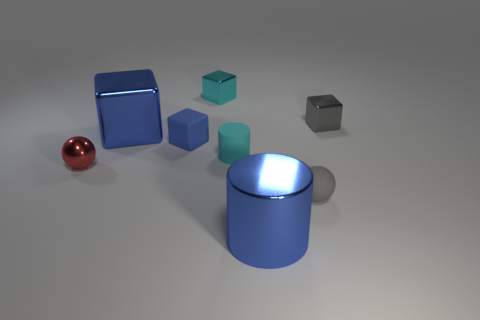What is the lighting situation in this scene? The objects in this scene are illuminated with what appears to be a single, diffused light source coming from the upper right, as evidenced by the shadows cast to the lower left of the objects and the highlights on the upper right sides of the objects. 